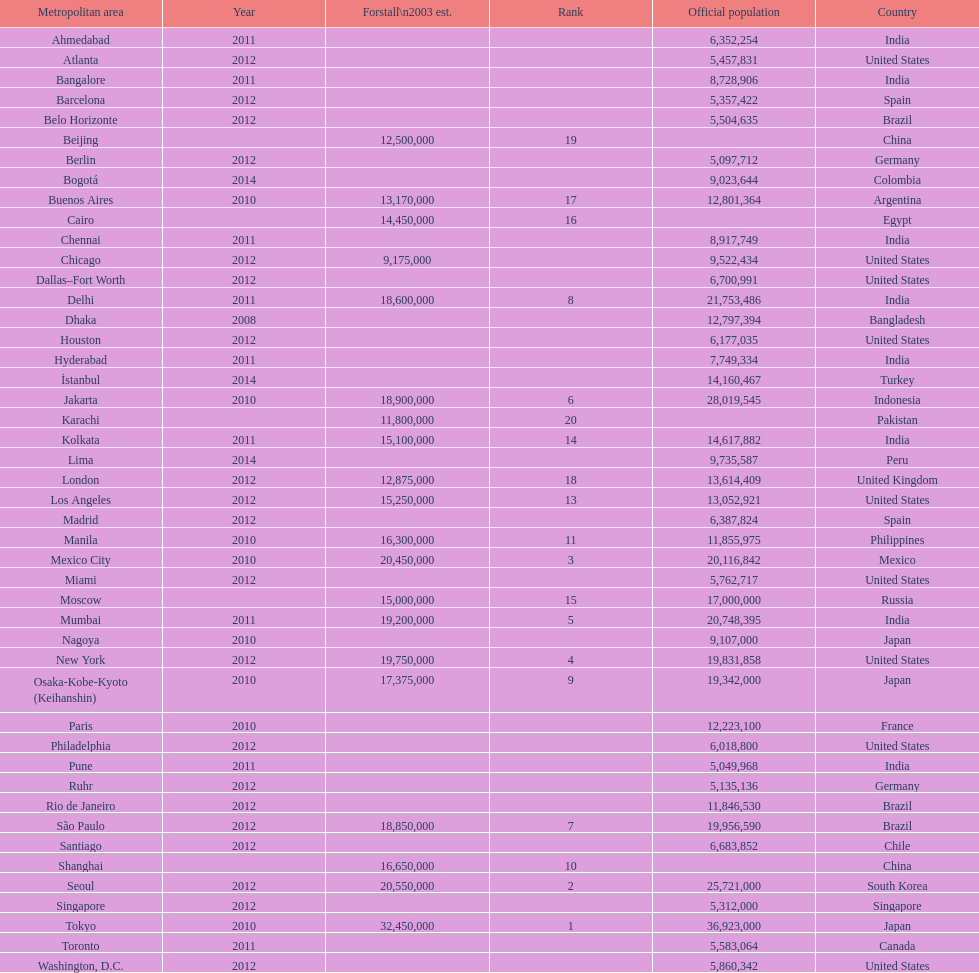Which area is listed above chicago? Chennai. 